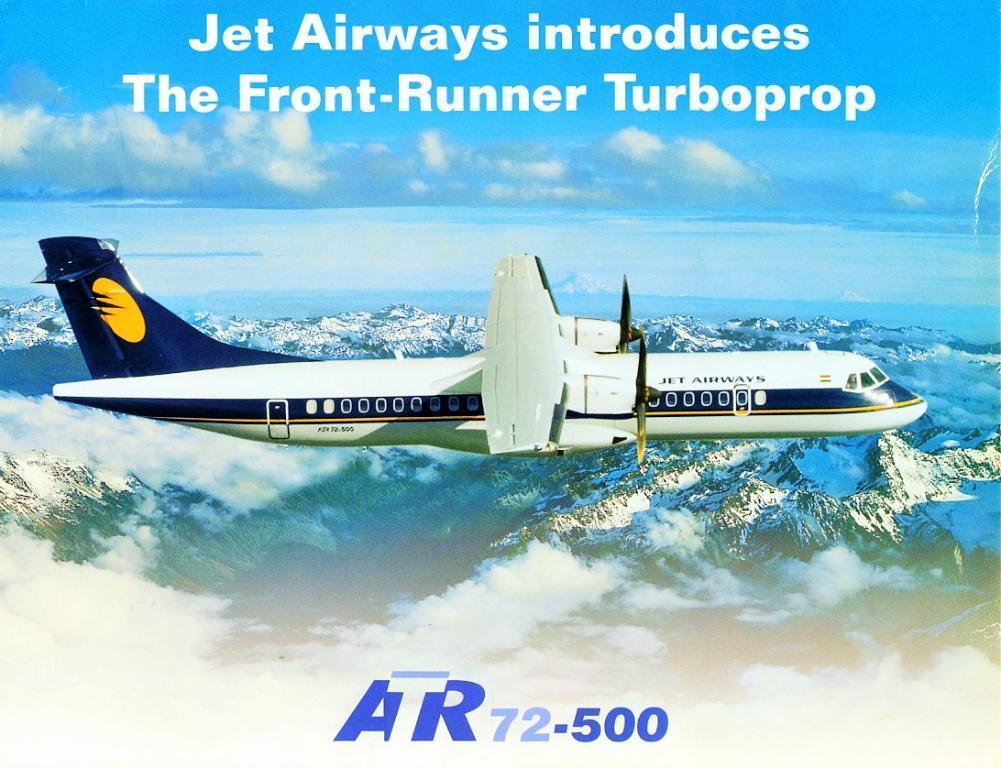Describe this image in one or two sentences. This is a picture of a poster. We can see the clouds in the sky. In this picture we can see an airplane, hills and some information. 